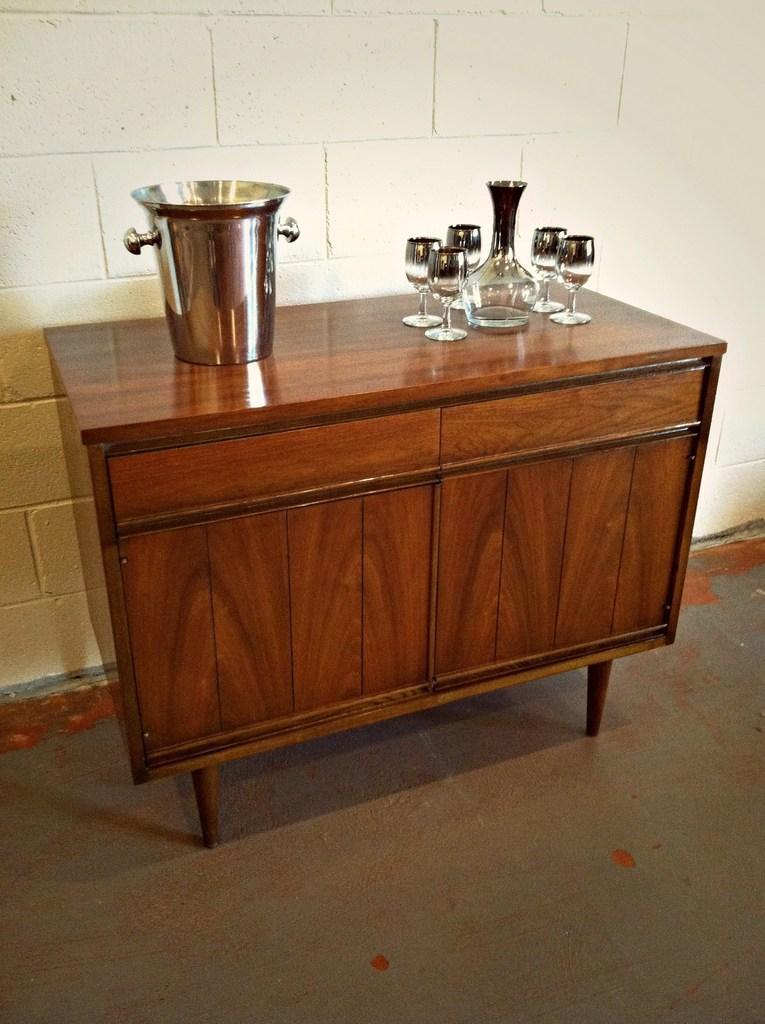Can you describe this image briefly? This picture seems to be clicked inside the room. In the center we can see a wooden cabinet on the top of which a jar and glasses and some other objects are placed. In the background we can see the wall and some other objects. 